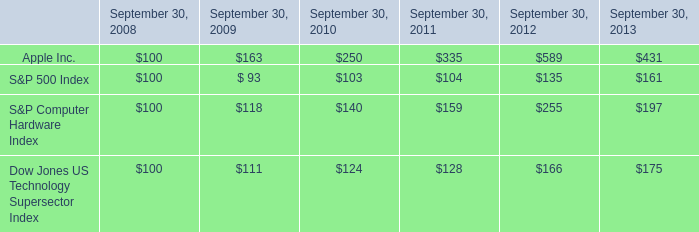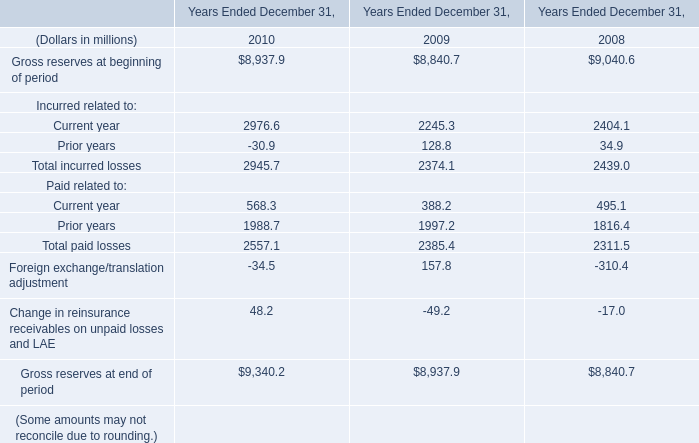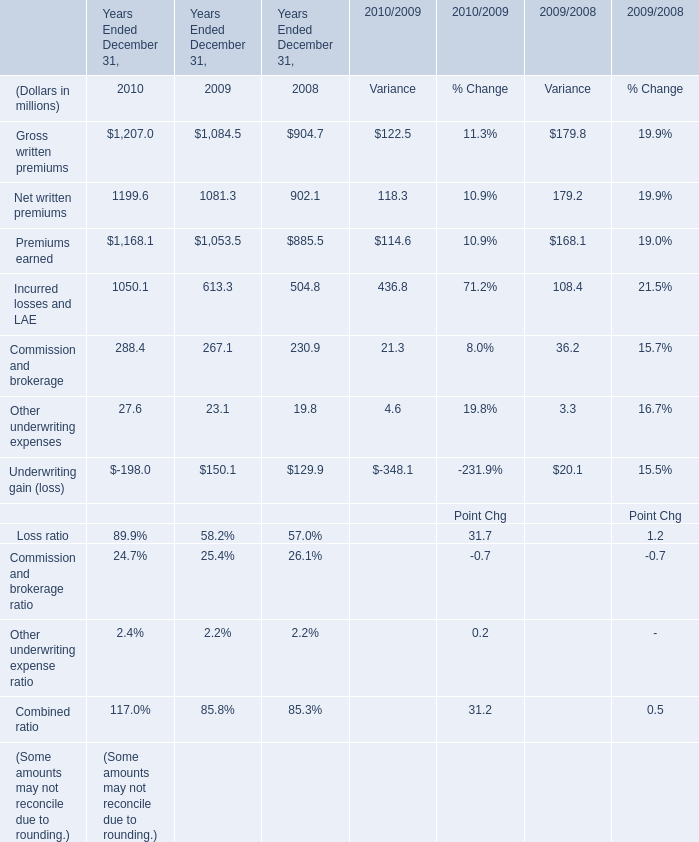What is the growing rate of other underwriting expenses in the year with the most Premiums earned? (in %) 
Computations: ((27.6 - 23.1) / 23.1)
Answer: 0.19481. 